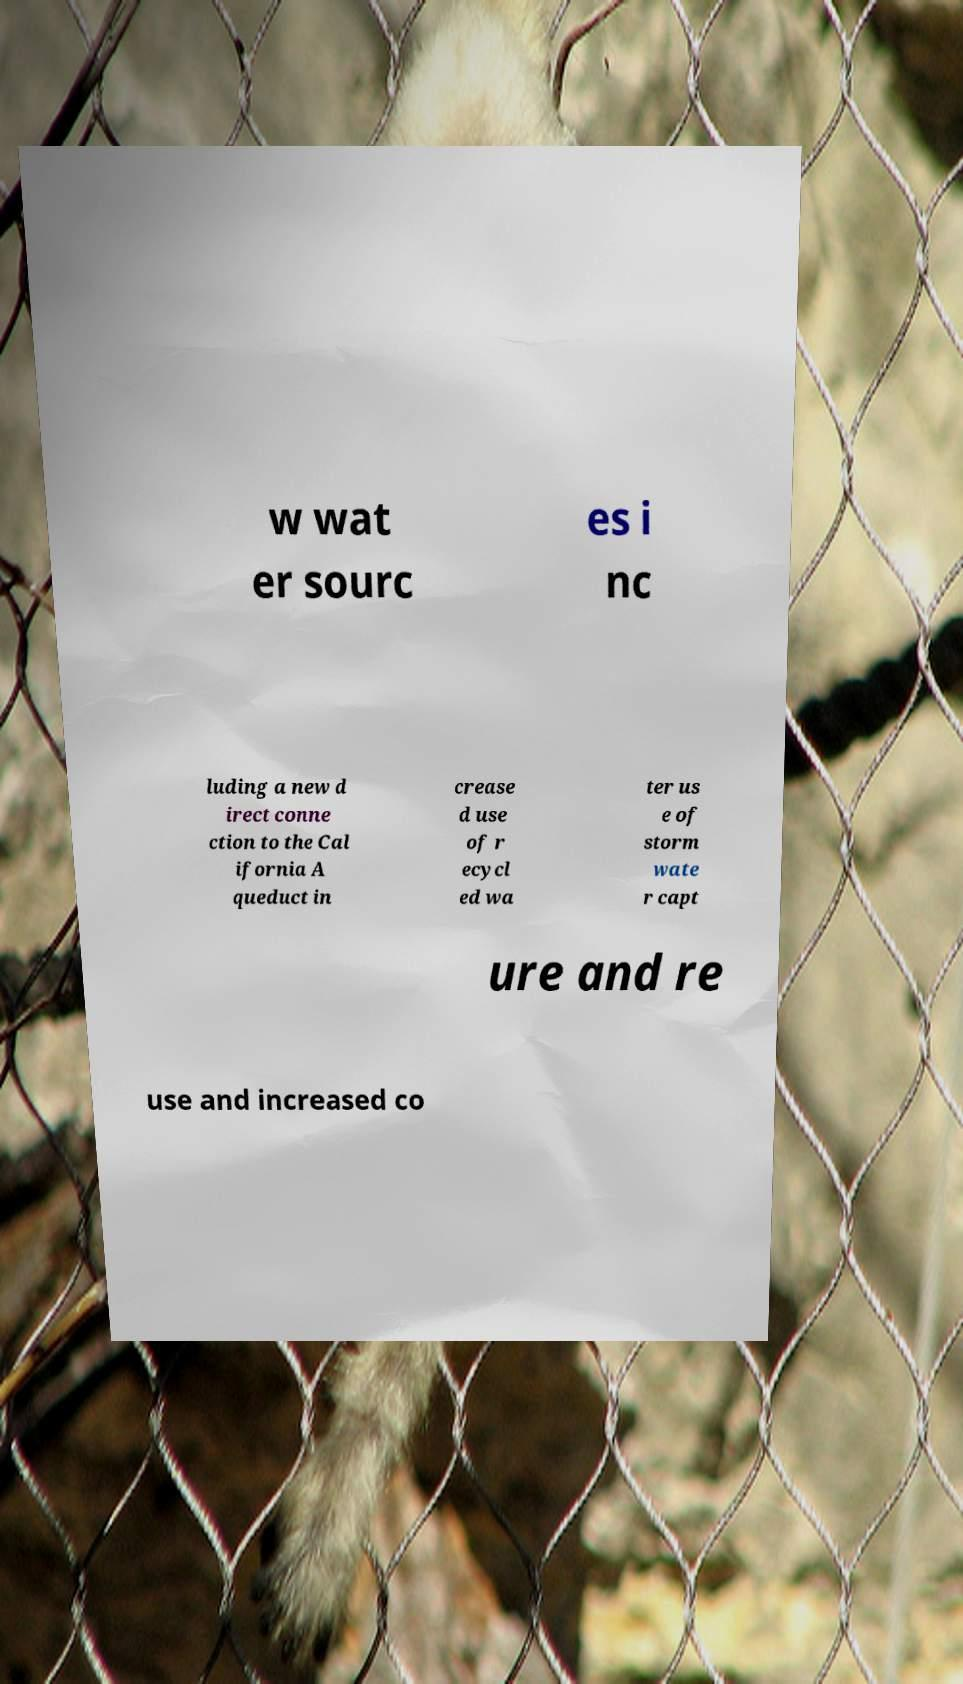Could you assist in decoding the text presented in this image and type it out clearly? w wat er sourc es i nc luding a new d irect conne ction to the Cal ifornia A queduct in crease d use of r ecycl ed wa ter us e of storm wate r capt ure and re use and increased co 